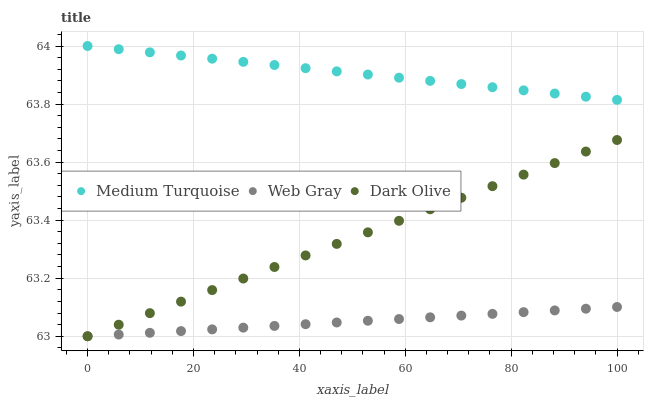Does Web Gray have the minimum area under the curve?
Answer yes or no. Yes. Does Medium Turquoise have the maximum area under the curve?
Answer yes or no. Yes. Does Medium Turquoise have the minimum area under the curve?
Answer yes or no. No. Does Web Gray have the maximum area under the curve?
Answer yes or no. No. Is Dark Olive the smoothest?
Answer yes or no. Yes. Is Web Gray the roughest?
Answer yes or no. Yes. Is Medium Turquoise the smoothest?
Answer yes or no. No. Is Medium Turquoise the roughest?
Answer yes or no. No. Does Dark Olive have the lowest value?
Answer yes or no. Yes. Does Medium Turquoise have the lowest value?
Answer yes or no. No. Does Medium Turquoise have the highest value?
Answer yes or no. Yes. Does Web Gray have the highest value?
Answer yes or no. No. Is Web Gray less than Medium Turquoise?
Answer yes or no. Yes. Is Medium Turquoise greater than Dark Olive?
Answer yes or no. Yes. Does Dark Olive intersect Web Gray?
Answer yes or no. Yes. Is Dark Olive less than Web Gray?
Answer yes or no. No. Is Dark Olive greater than Web Gray?
Answer yes or no. No. Does Web Gray intersect Medium Turquoise?
Answer yes or no. No. 